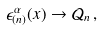<formula> <loc_0><loc_0><loc_500><loc_500>\epsilon _ { ( n ) } ^ { \alpha } ( x ) \rightarrow \mathcal { Q } _ { n } \, ,</formula> 